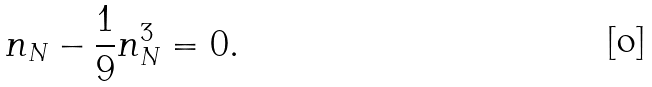Convert formula to latex. <formula><loc_0><loc_0><loc_500><loc_500>n _ { N } - \frac { 1 } { 9 } n _ { N } ^ { 3 } = 0 .</formula> 